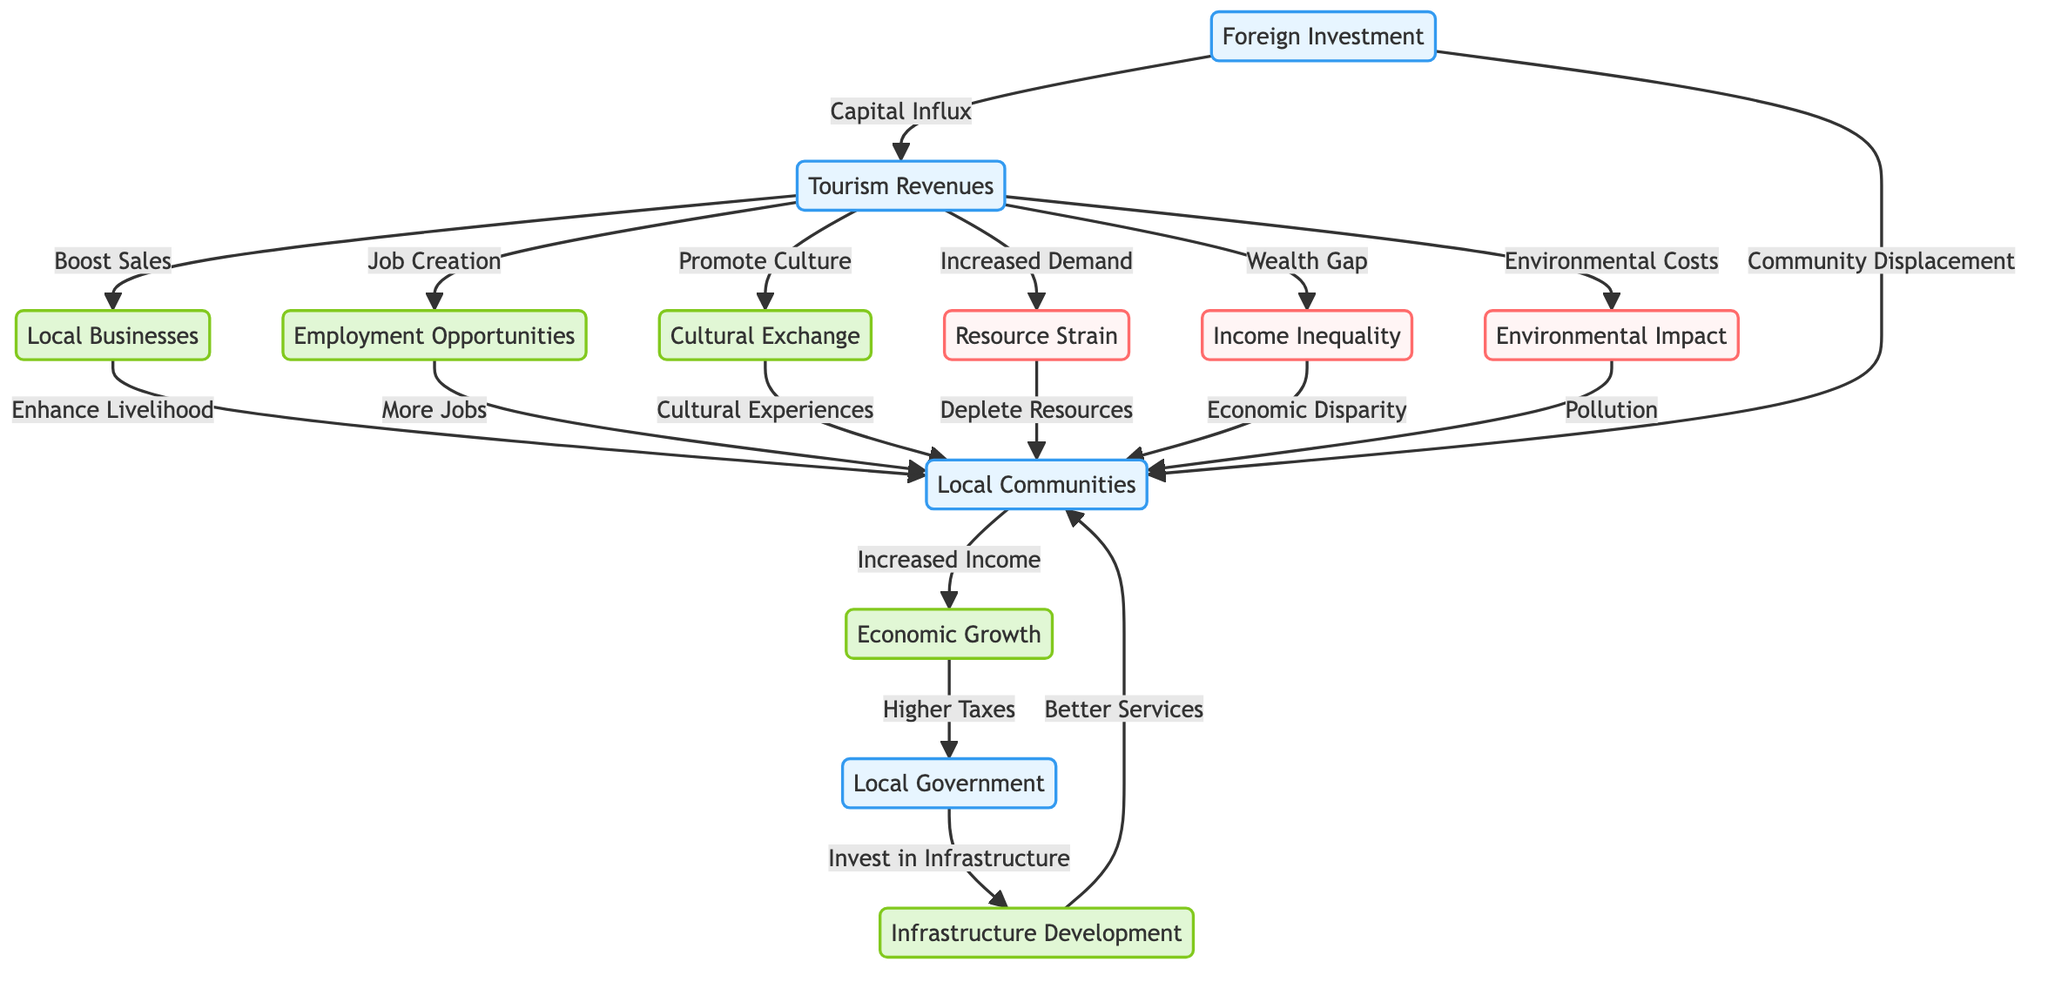What are the positive impacts of tourism on local communities? The diagram illustrates several positive impacts linked to tourism. These include enhanced livelihood through local businesses, job creation, increased economic growth, infrastructure development, and cultural exchange.
Answer: Enhanced livelihood, job creation, economic growth, infrastructure development, cultural exchange What negative impact is associated with resource strain from tourism? The diagram shows that increased demand from tourism leads to resource strain, which then causes the depletion of resources in local communities. This relationship is demonstrated through the flow from tourism revenues to resource strain and then to local communities.
Answer: Deplete Resources How many positive impacts are identified in the diagram? Counting the nodes representing positive impacts, we find five: enhanced livelihood, job creation, economic growth, infrastructure development, and cultural exchange. Thus, the total number of positive impacts is five.
Answer: 5 What leads to income inequality as shown in the diagram? The diagram indicates a direct causal flow where tourism revenues lead to a wealth gap, which subsequently creates economic disparity. This indicates that income inequality stems from the revenue generated by tourism.
Answer: Wealth Gap What are the consequences of environmental impact due to tourism? Environmental impacts are indicated in the diagram, showing that tourism can lead to pollution in local communities. This shows a direct flow from environmental costs incurred by tourism to pollution affecting local communities.
Answer: Pollution What is the role of local government as shown in the diagram? The diagram highlights that local government benefits from higher taxes due to economic growth, which is generated by increased income and job opportunities from tourism. This shows that the local government plays a crucial role in utilizing tourism revenues for community investment.
Answer: Invest in Infrastructure What effect does foreign investment have on tourism revenues? The diagram states that foreign investment contributes to a capital influx which boosts tourism revenues. This indicates that foreign investment is a vital source of financing that positively affects tourism in the local economy.
Answer: Capital Influx How does cultural exchange positively affect local communities? The diagram indicates that cultural exchange is promoted by tourism, resulting in cultural experiences for local communities. This highlights the positive relationship between tourism and cultural engagement.
Answer: Cultural Experiences 